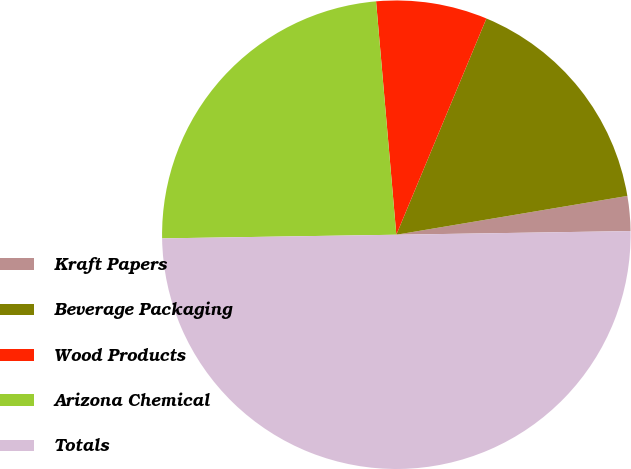<chart> <loc_0><loc_0><loc_500><loc_500><pie_chart><fcel>Kraft Papers<fcel>Beverage Packaging<fcel>Wood Products<fcel>Arizona Chemical<fcel>Totals<nl><fcel>2.4%<fcel>16.07%<fcel>7.66%<fcel>23.87%<fcel>50.0%<nl></chart> 